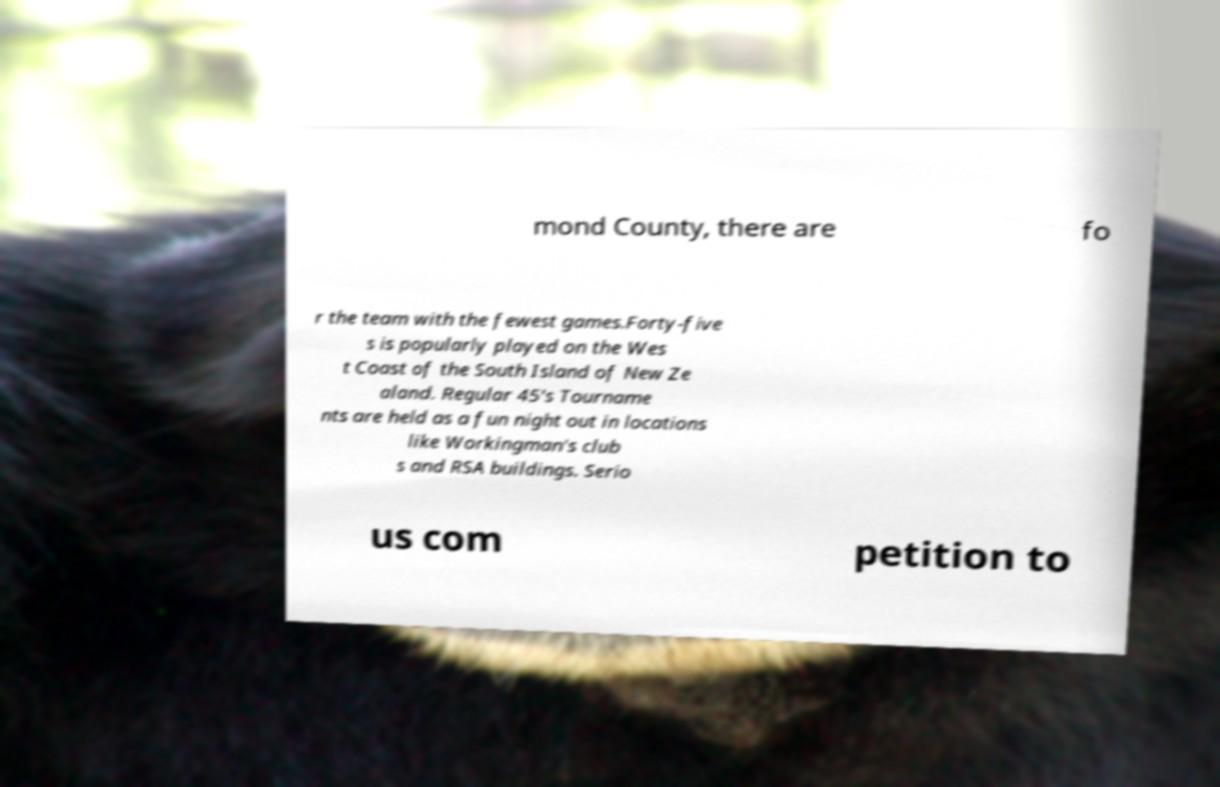For documentation purposes, I need the text within this image transcribed. Could you provide that? mond County, there are fo r the team with the fewest games.Forty-five s is popularly played on the Wes t Coast of the South Island of New Ze aland. Regular 45's Tourname nts are held as a fun night out in locations like Workingman's club s and RSA buildings. Serio us com petition to 